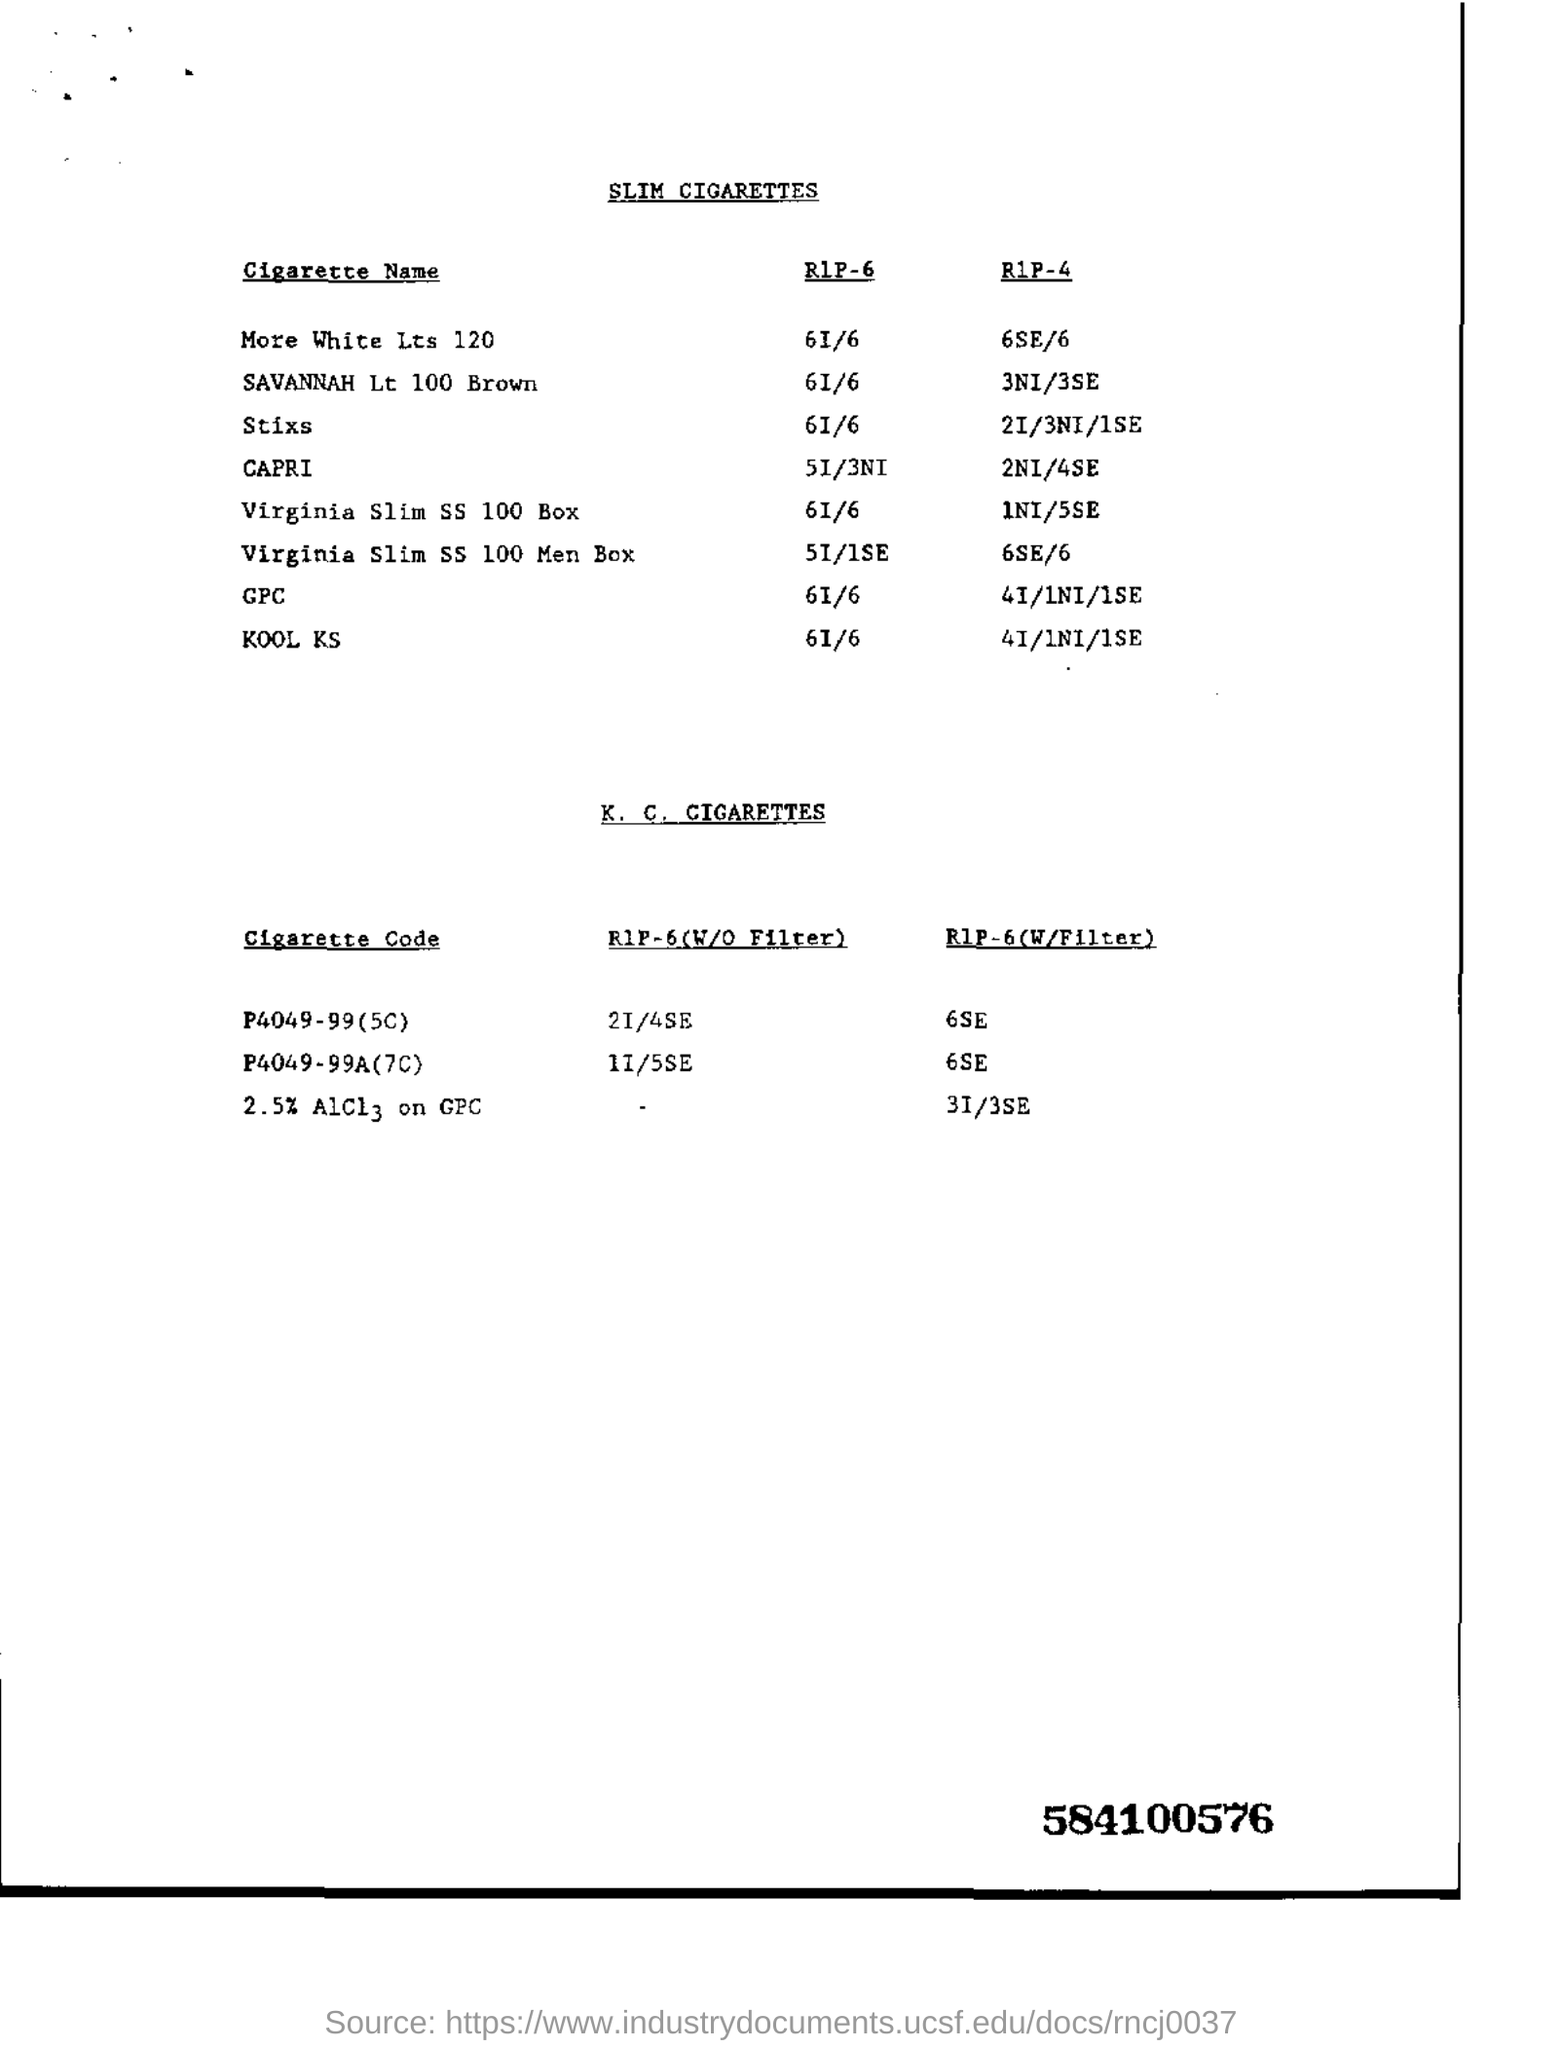Indicate a few pertinent items in this graphic. The RIP-6 value for KOOL KS is 6I/6.. The heading of the first table is "Slim Cigarettes. The heading of the second table is "K. C. Cigarettes. The RIP-6 (without filter) cigarette code is P4049-99 (version 5C). The manufacturer of this cigarette is unknown. 